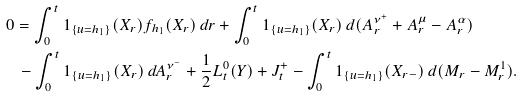Convert formula to latex. <formula><loc_0><loc_0><loc_500><loc_500>0 & = \int _ { 0 } ^ { t } 1 _ { \{ u = h _ { 1 } \} } ( X _ { r } ) f _ { h _ { 1 } } ( X _ { r } ) \, d r + \int _ { 0 } ^ { t } 1 _ { \{ u = h _ { 1 } \} } ( X _ { r } ) \, d ( A _ { r } ^ { \nu ^ { + } } + A _ { r } ^ { \mu } - A _ { r } ^ { \alpha } ) \\ & \, - \int _ { 0 } ^ { t } 1 _ { \{ u = h _ { 1 } \} } ( X _ { r } ) \, d A _ { r } ^ { \nu ^ { - } } + \frac { 1 } { 2 } L _ { t } ^ { 0 } ( Y ) + J _ { t } ^ { + } - \int _ { 0 } ^ { t } 1 _ { \{ u = h _ { 1 } \} } ( X _ { r - } ) \, d ( M _ { r } - M _ { r } ^ { 1 } ) .</formula> 